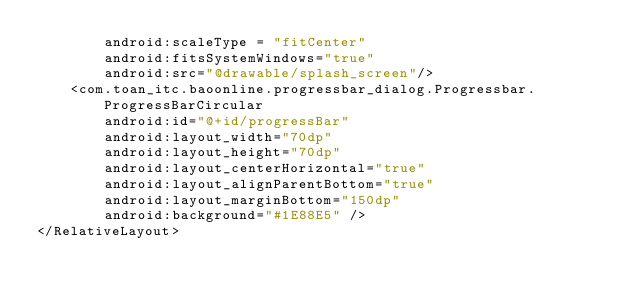<code> <loc_0><loc_0><loc_500><loc_500><_XML_>        android:scaleType = "fitCenter"
        android:fitsSystemWindows="true"
        android:src="@drawable/splash_screen"/>
    <com.toan_itc.baoonline.progressbar_dialog.Progressbar.ProgressBarCircular
        android:id="@+id/progressBar"
        android:layout_width="70dp"
        android:layout_height="70dp"
        android:layout_centerHorizontal="true"
        android:layout_alignParentBottom="true"
        android:layout_marginBottom="150dp"
        android:background="#1E88E5" />
</RelativeLayout>
</code> 